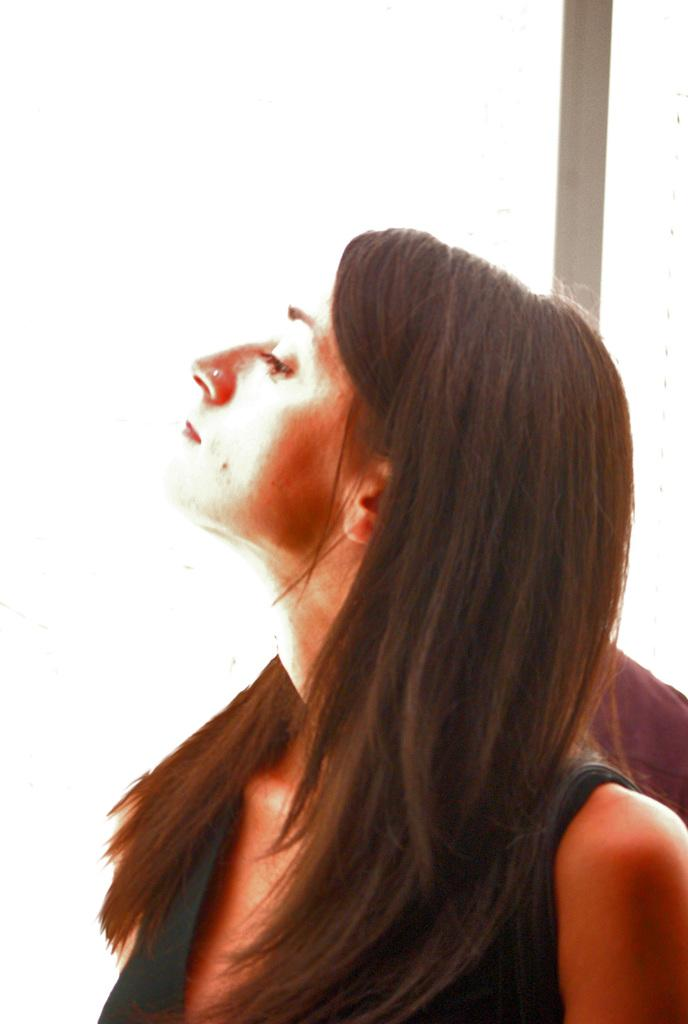What is the main subject of the image? There is a woman in the image. What is the woman wearing? The woman is wearing a dress. What is the woman doing in the image? The woman is watching something. What can be seen in the background of the image? The background of the image is white in color. What else is present in the image besides the woman? There is a pole in the image. What type of camera can be seen in the woman's hand in the image? There is no camera visible in the woman's hand in the image. What kind of noise is coming from the pole in the image? There is no noise coming from the pole in the image, as it is a stationary object. 